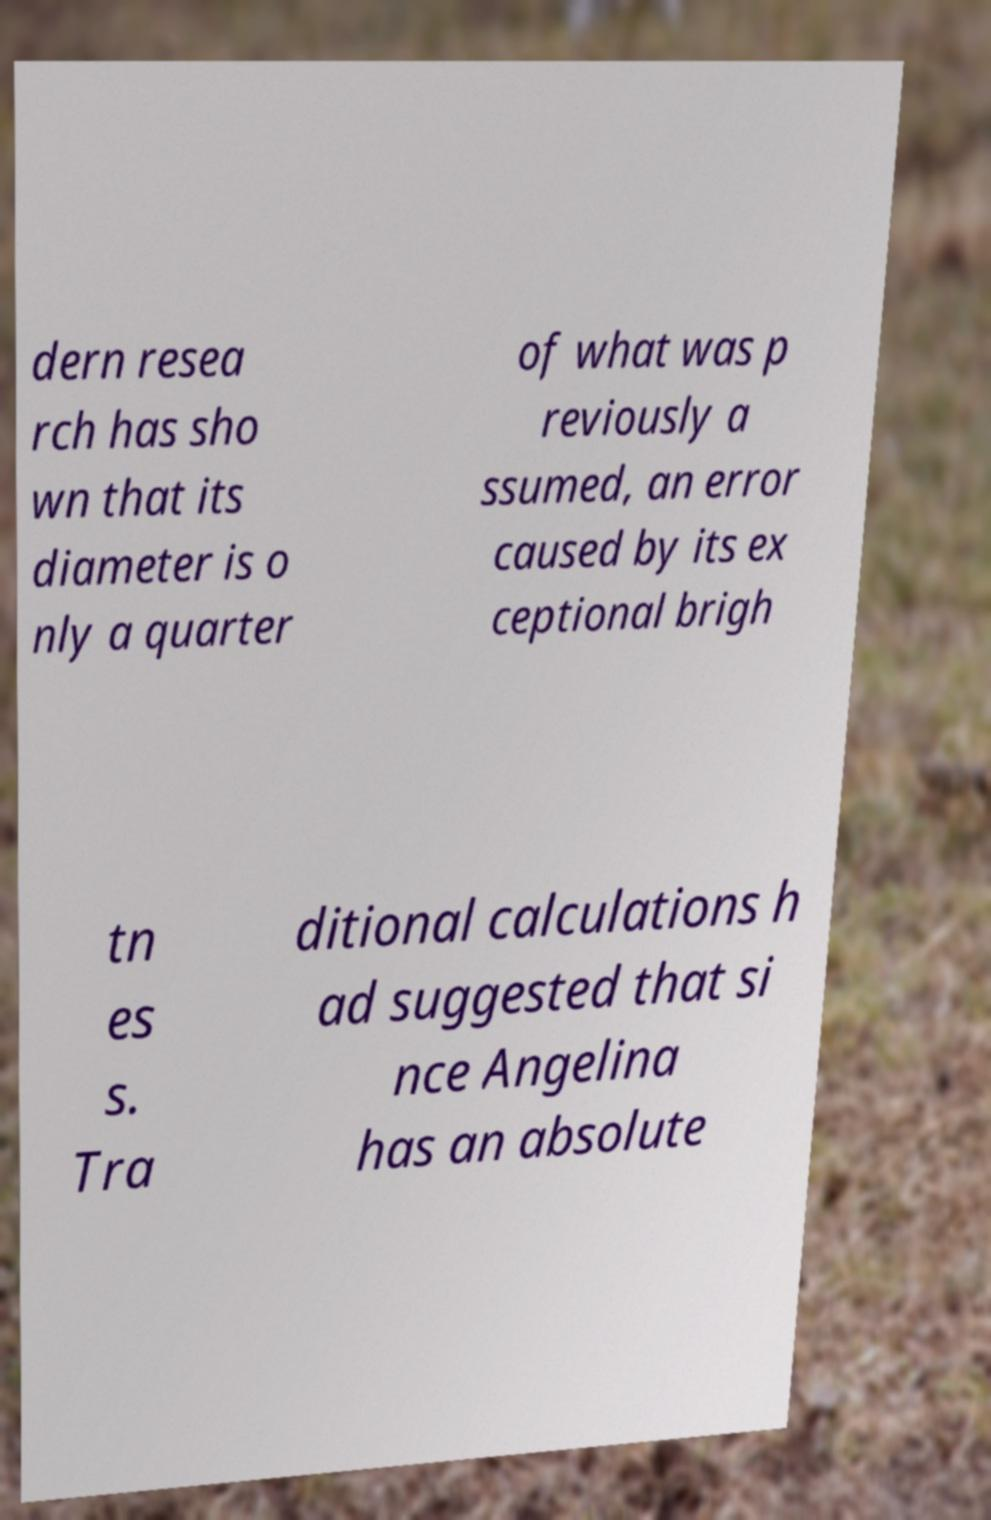I need the written content from this picture converted into text. Can you do that? dern resea rch has sho wn that its diameter is o nly a quarter of what was p reviously a ssumed, an error caused by its ex ceptional brigh tn es s. Tra ditional calculations h ad suggested that si nce Angelina has an absolute 